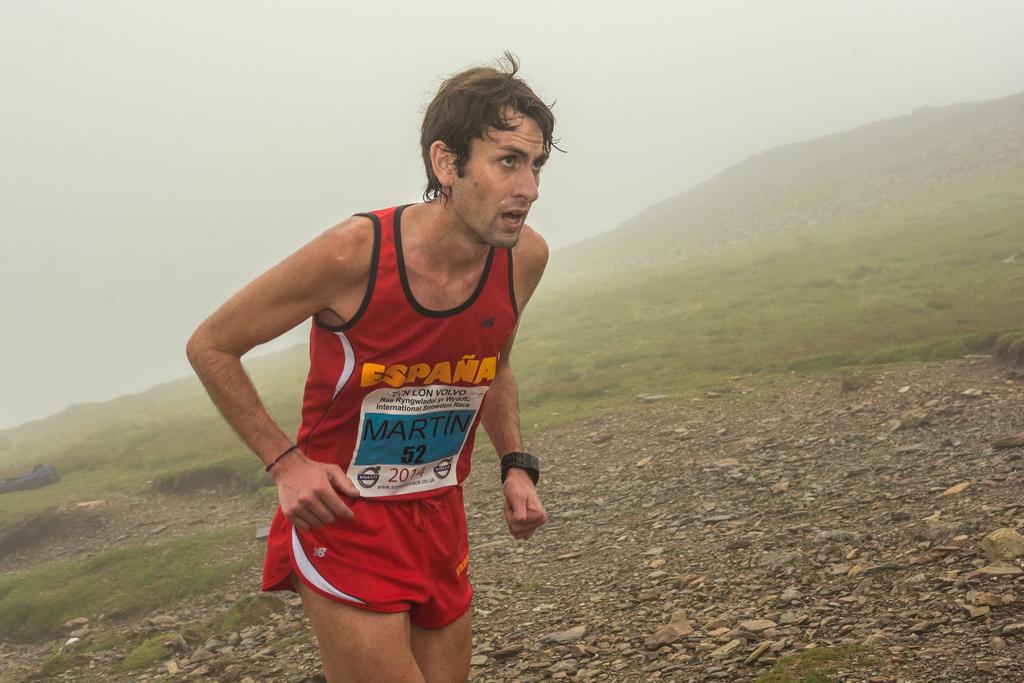<image>
Present a compact description of the photo's key features. A runner for Espana is wearing the number 52 and running up a hill. 